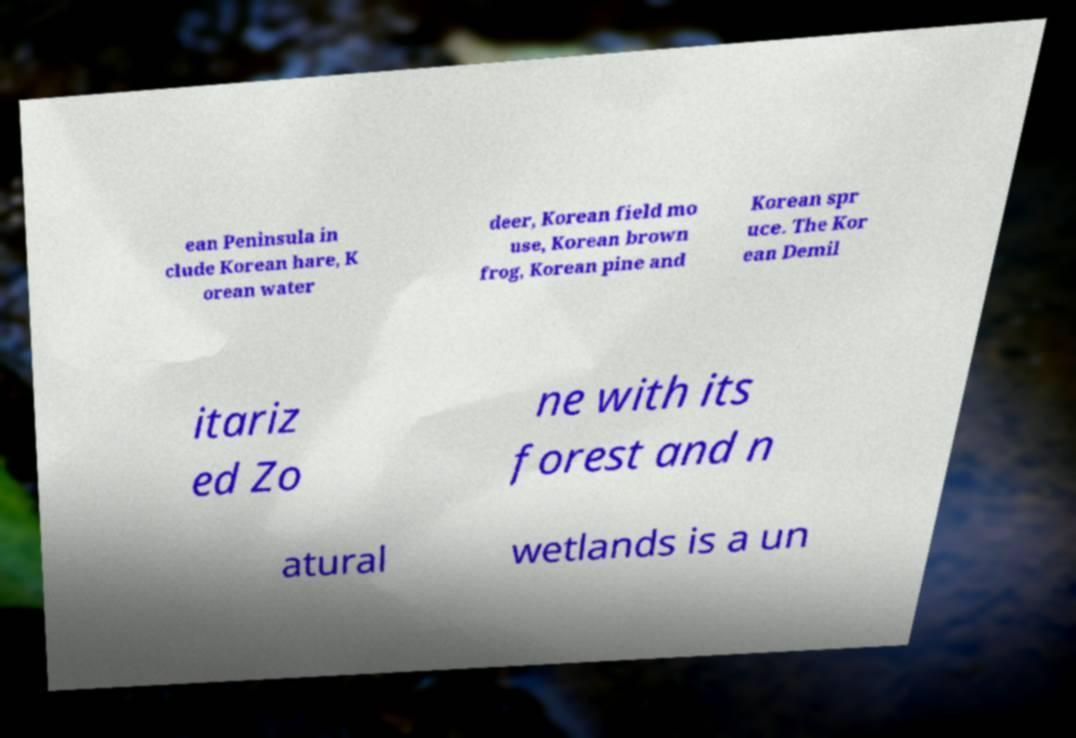There's text embedded in this image that I need extracted. Can you transcribe it verbatim? ean Peninsula in clude Korean hare, K orean water deer, Korean field mo use, Korean brown frog, Korean pine and Korean spr uce. The Kor ean Demil itariz ed Zo ne with its forest and n atural wetlands is a un 